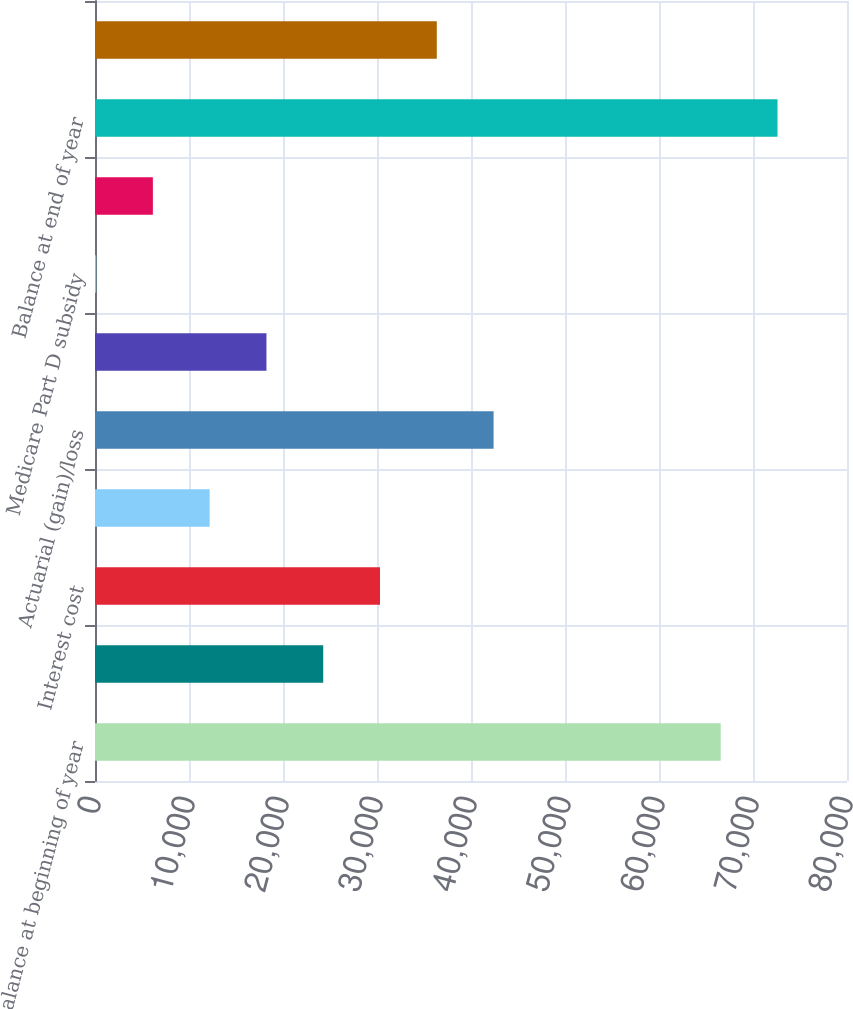Convert chart. <chart><loc_0><loc_0><loc_500><loc_500><bar_chart><fcel>Balance at beginning of year<fcel>Service cost<fcel>Interest cost<fcel>Plan participant contributions<fcel>Actuarial (gain)/loss<fcel>Benefits paid<fcel>Medicare Part D subsidy<fcel>Early Retiree Reinsurance<fcel>Balance at end of year<fcel>Employer contributions<nl><fcel>66567<fcel>24280<fcel>30321<fcel>12198<fcel>42403<fcel>18239<fcel>116<fcel>6157<fcel>72608<fcel>36362<nl></chart> 